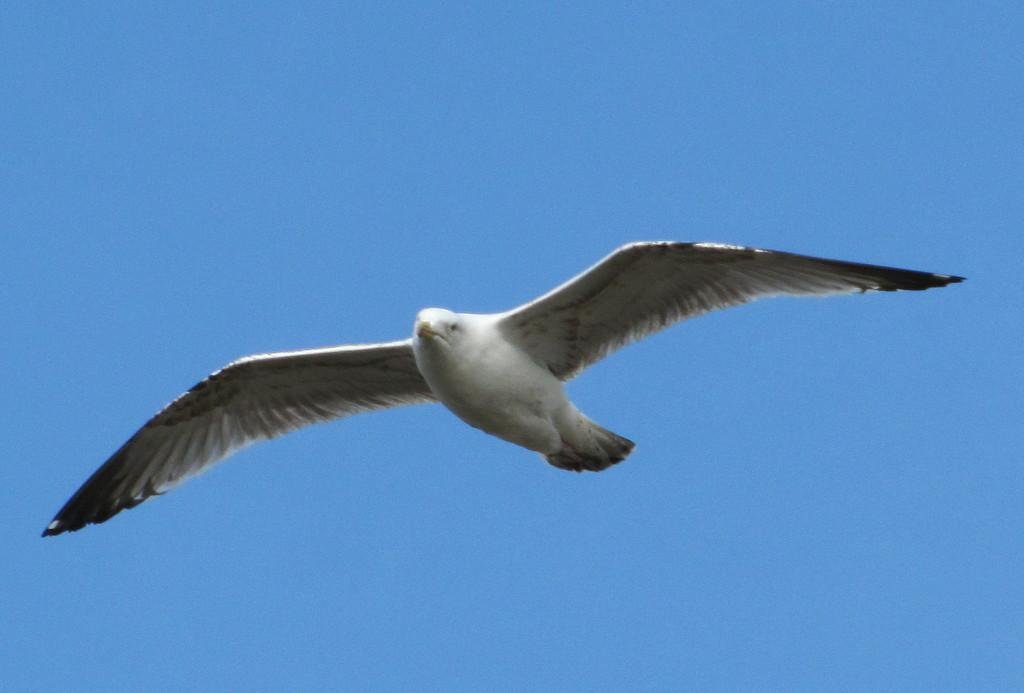What type of animal can be seen in the sky in the image? There is a bird in the sky in the image. Can you describe the bird's location in the sky? The bird is flying in the sky in the image. What is the bird's primary function in the image? The bird's primary function in the image is to be a subject of observation. What type of rings can be seen on the bird's legs in the image? There are no rings visible on the bird's legs in the image. What type of wool is the bird using to fly in the image? Birds do not use wool to fly, and there is no wool visible in the image. 